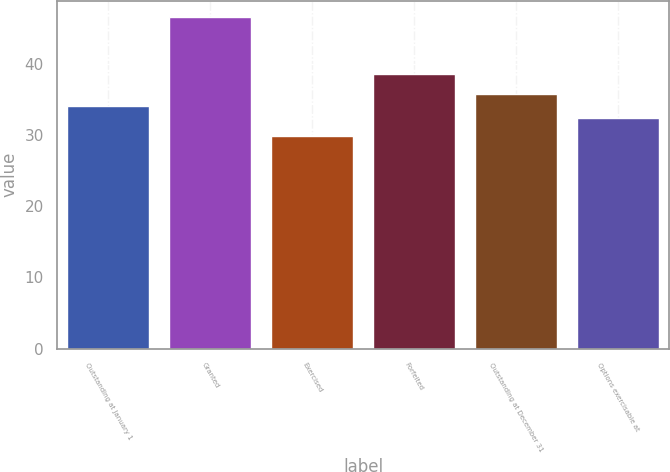<chart> <loc_0><loc_0><loc_500><loc_500><bar_chart><fcel>Outstanding at January 1<fcel>Granted<fcel>Exercised<fcel>Forfeited<fcel>Outstanding at December 31<fcel>Options exercisable at<nl><fcel>34.08<fcel>46.58<fcel>29.89<fcel>38.59<fcel>35.75<fcel>32.41<nl></chart> 